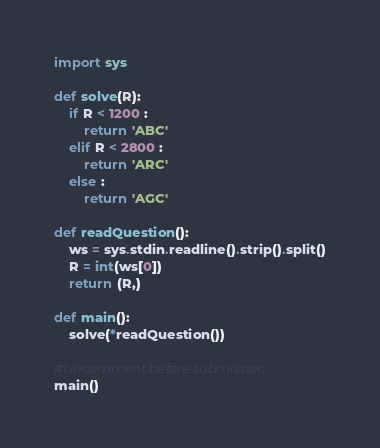<code> <loc_0><loc_0><loc_500><loc_500><_Python_>import sys

def solve(R):
    if R < 1200 :
        return 'ABC'
    elif R < 2800 :
        return 'ARC'
    else :
        return 'AGC'

def readQuestion():
    ws = sys.stdin.readline().strip().split()
    R = int(ws[0])
    return (R,)

def main():
    solve(*readQuestion())

#Uncomment before submission
main()</code> 